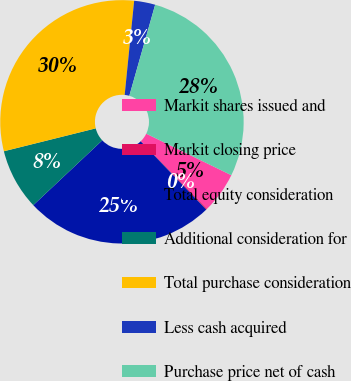<chart> <loc_0><loc_0><loc_500><loc_500><pie_chart><fcel>Markit shares issued and<fcel>Markit closing price<fcel>Total equity consideration<fcel>Additional consideration for<fcel>Total purchase consideration<fcel>Less cash acquired<fcel>Purchase price net of cash<nl><fcel>5.46%<fcel>0.14%<fcel>25.17%<fcel>8.12%<fcel>30.49%<fcel>2.8%<fcel>27.83%<nl></chart> 